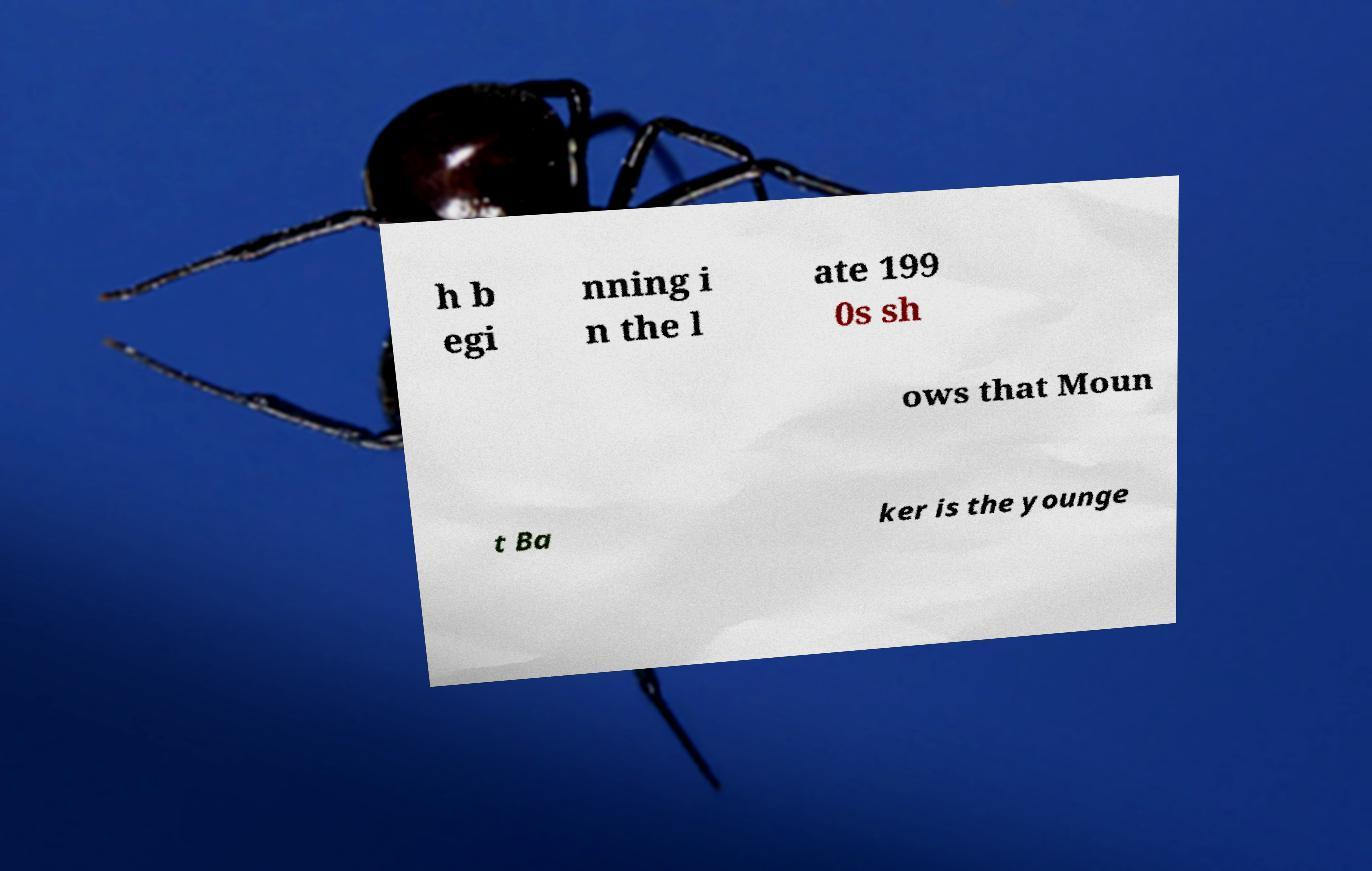Can you read and provide the text displayed in the image?This photo seems to have some interesting text. Can you extract and type it out for me? h b egi nning i n the l ate 199 0s sh ows that Moun t Ba ker is the younge 